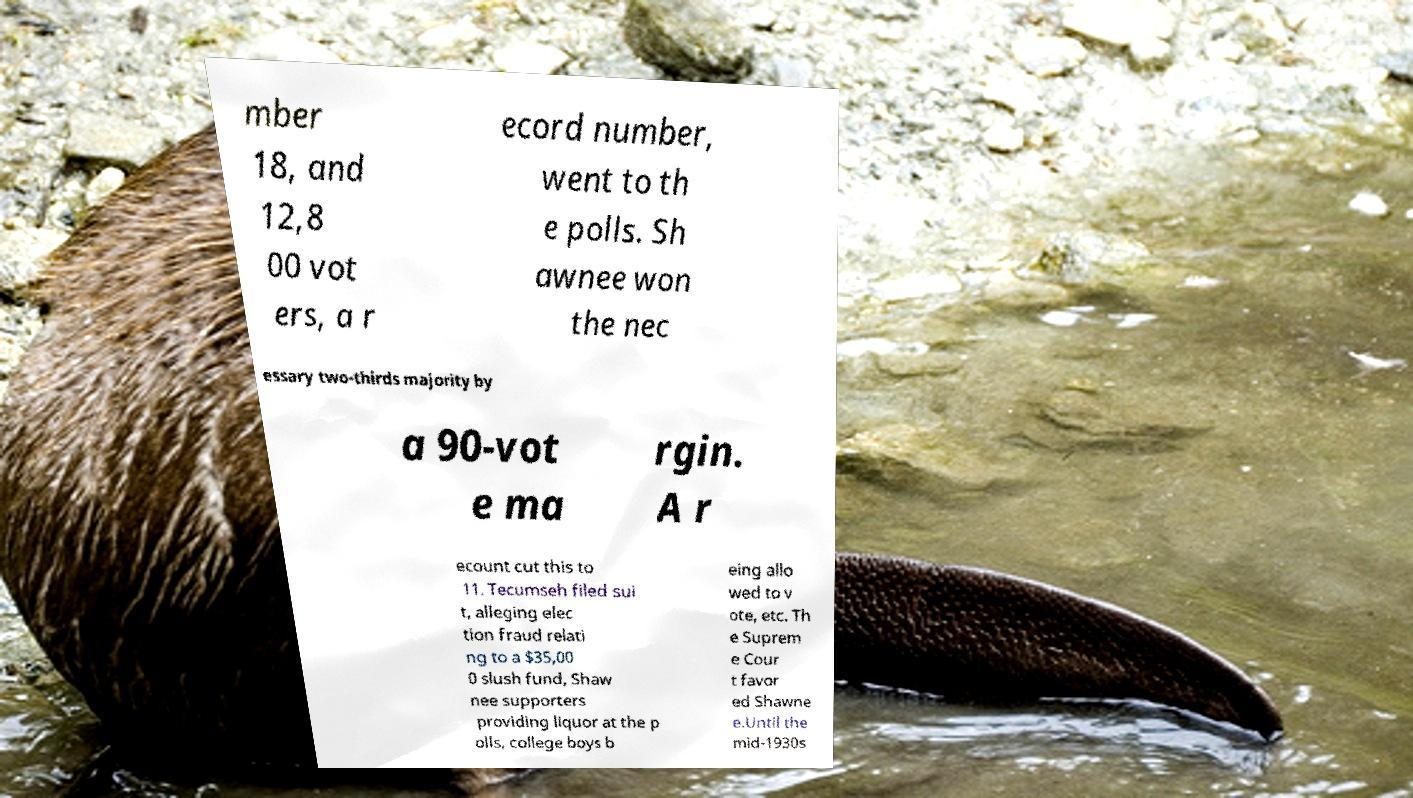Please identify and transcribe the text found in this image. mber 18, and 12,8 00 vot ers, a r ecord number, went to th e polls. Sh awnee won the nec essary two-thirds majority by a 90-vot e ma rgin. A r ecount cut this to 11. Tecumseh filed sui t, alleging elec tion fraud relati ng to a $35,00 0 slush fund, Shaw nee supporters providing liquor at the p olls, college boys b eing allo wed to v ote, etc. Th e Suprem e Cour t favor ed Shawne e.Until the mid-1930s 